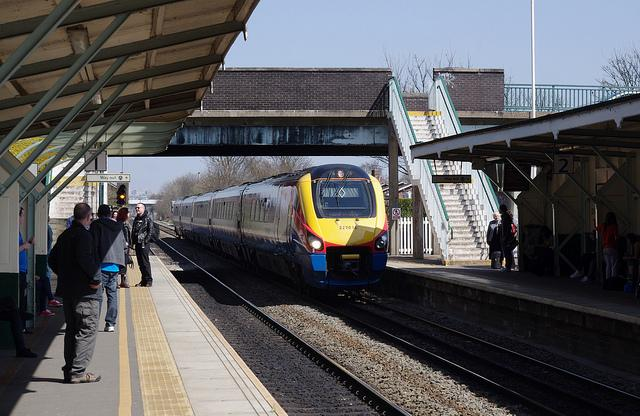Which platform services the train arriving now?

Choices:
A) right
B) none
C) left
D) last one right 